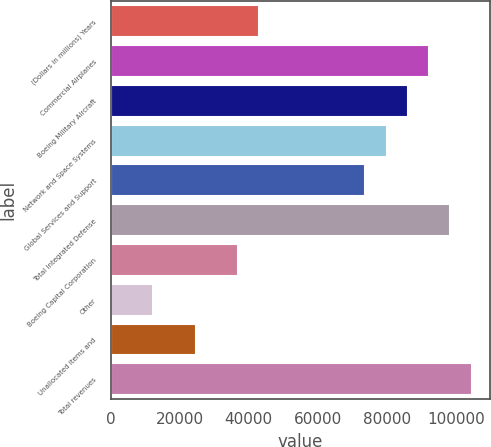<chart> <loc_0><loc_0><loc_500><loc_500><bar_chart><fcel>(Dollars in millions) Years<fcel>Commercial Airplanes<fcel>Boeing Military Aircraft<fcel>Network and Space Systems<fcel>Global Services and Support<fcel>Total Integrated Defense<fcel>Boeing Capital Corporation<fcel>Other<fcel>Unallocated items and<fcel>Total revenues<nl><fcel>43073.7<fcel>92290.5<fcel>86138.4<fcel>79986.3<fcel>73834.2<fcel>98442.6<fcel>36921.6<fcel>12313.2<fcel>24617.4<fcel>104595<nl></chart> 